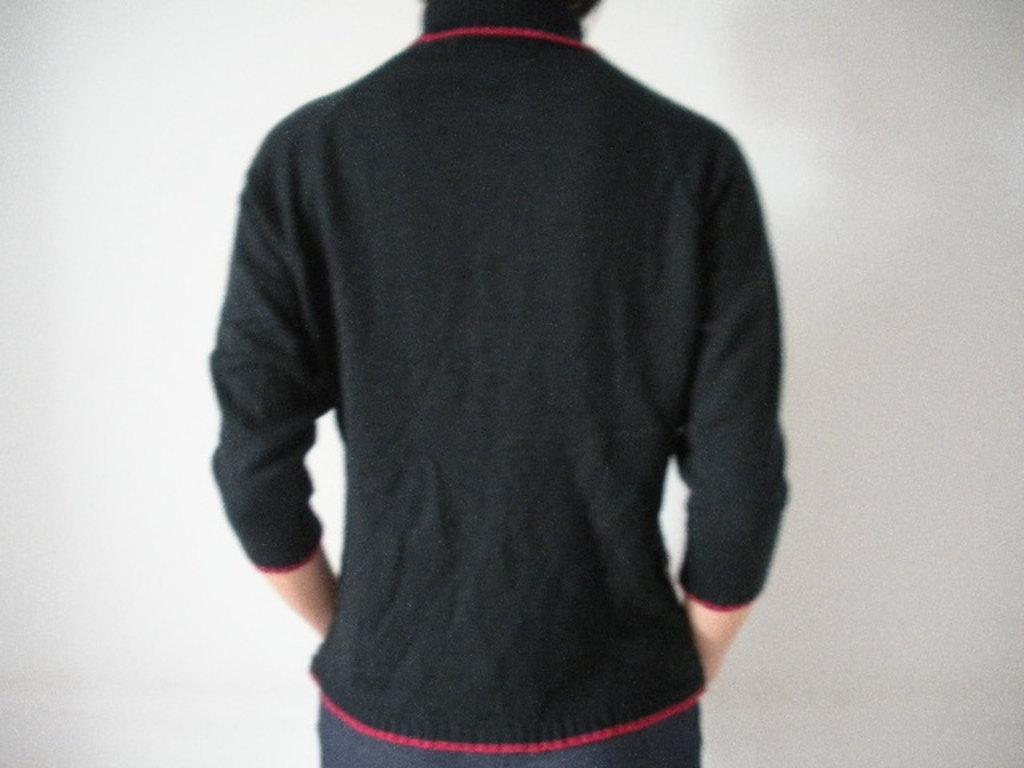Describe this image in one or two sentences. In this image we can see a person, and the background is white in color. 